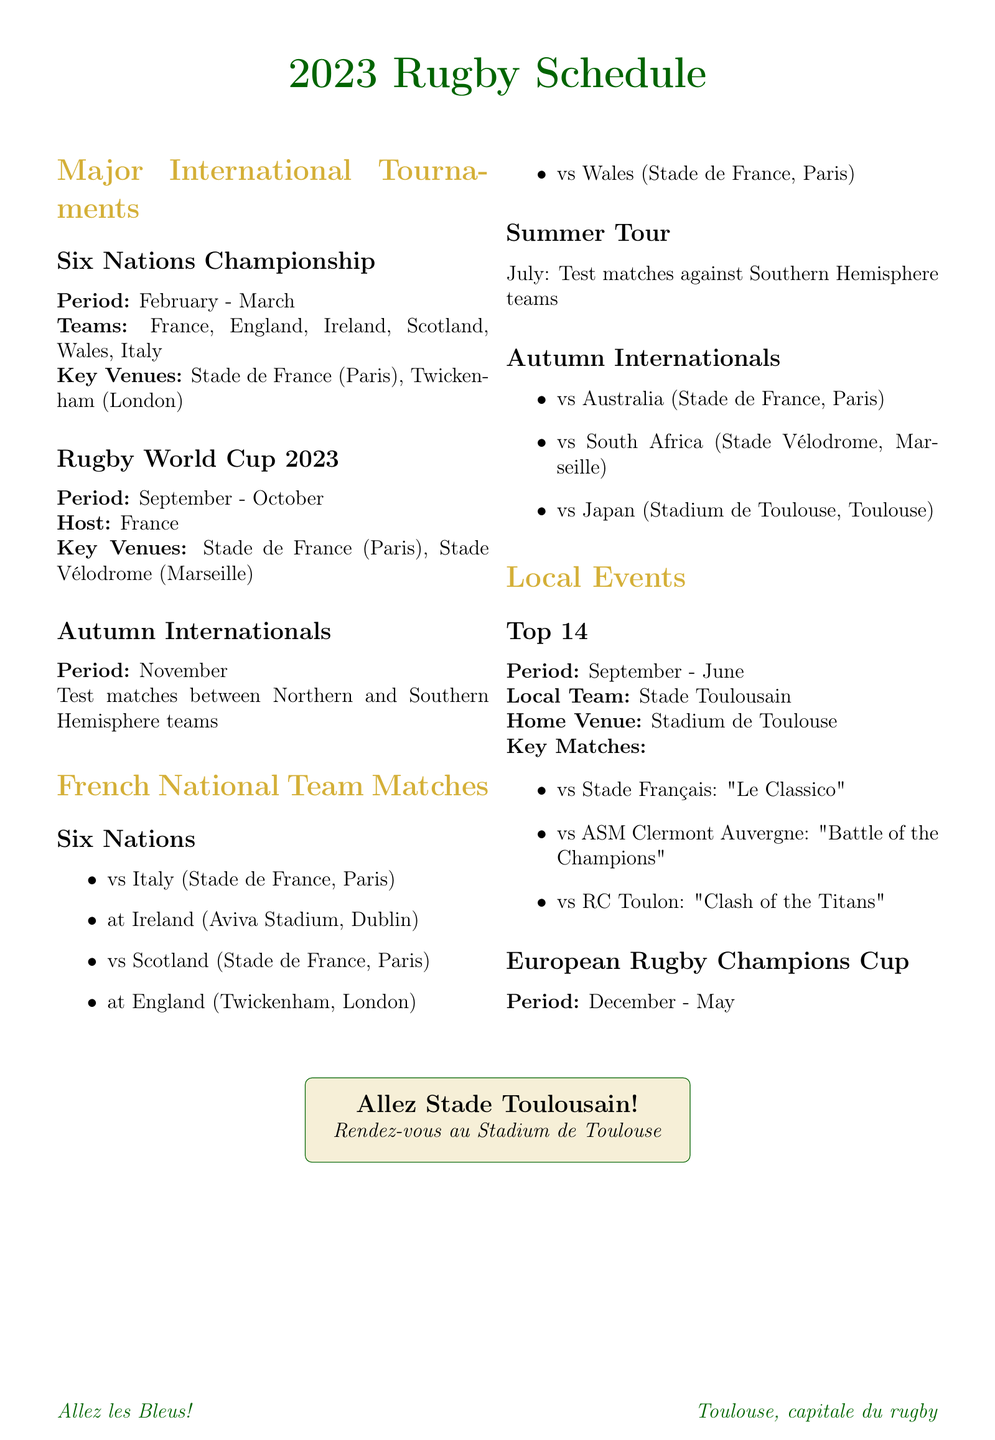what is the main tournament held in February and March? The main tournament during February and March is the Six Nations Championship.
Answer: Six Nations Championship where will the Rugby World Cup 2023 be hosted? The Rugby World Cup 2023 will be hosted in France.
Answer: France who are France's first competitors in the Six Nations? France's first competitor in the Six Nations is Italy.
Answer: Italy how many matches will France play in the Six Nations? France will play five matches in the Six Nations.
Answer: five what is the period for the Autumn Internationals? The period for the Autumn Internationals is November.
Answer: November which venue will host France's match against Japan in the Autumn Internationals? The venue for France's match against Japan is the Stadium de Toulouse.
Answer: Stadium de Toulouse what months does the Top 14 rugby league run? The Top 14 rugby league runs from September to June.
Answer: September - June how many key matches are listed for the Top 14? There are three key matches listed for the Top 14.
Answer: three what is the local team for the Top 14 rugby league? The local team for the Top 14 rugby league is Stade Toulousain.
Answer: Stade Toulousain 